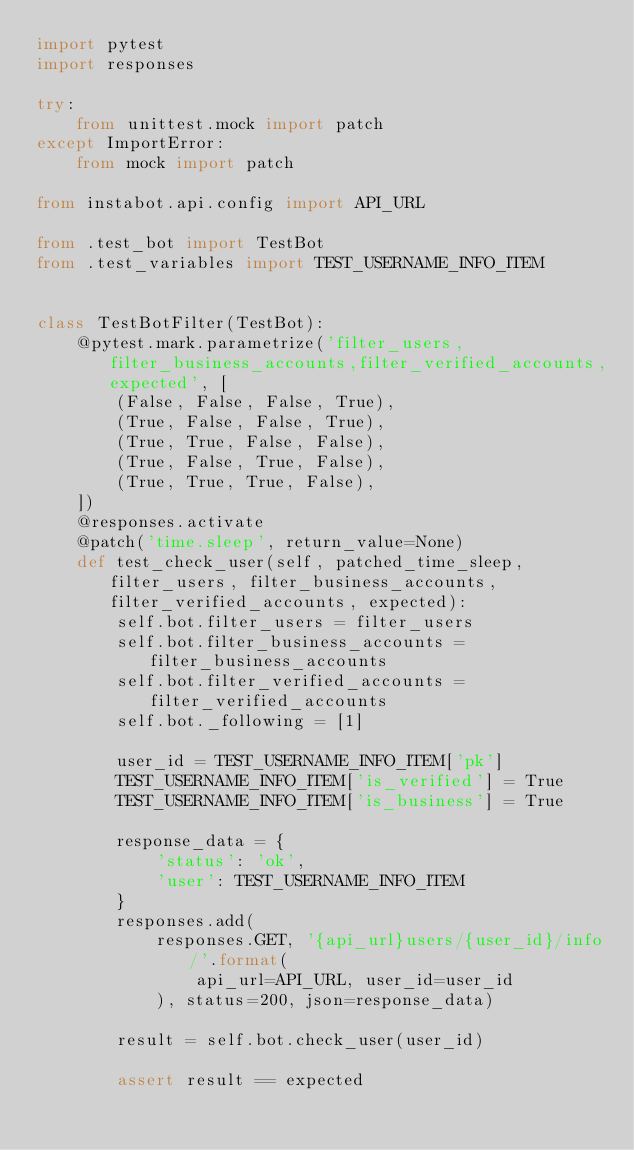Convert code to text. <code><loc_0><loc_0><loc_500><loc_500><_Python_>import pytest
import responses

try:
    from unittest.mock import patch
except ImportError:
    from mock import patch

from instabot.api.config import API_URL

from .test_bot import TestBot
from .test_variables import TEST_USERNAME_INFO_ITEM


class TestBotFilter(TestBot):
    @pytest.mark.parametrize('filter_users,filter_business_accounts,filter_verified_accounts,expected', [
        (False, False, False, True),
        (True, False, False, True),
        (True, True, False, False),
        (True, False, True, False),
        (True, True, True, False),
    ])
    @responses.activate
    @patch('time.sleep', return_value=None)
    def test_check_user(self, patched_time_sleep, filter_users, filter_business_accounts, filter_verified_accounts, expected):
        self.bot.filter_users = filter_users
        self.bot.filter_business_accounts = filter_business_accounts
        self.bot.filter_verified_accounts = filter_verified_accounts
        self.bot._following = [1]

        user_id = TEST_USERNAME_INFO_ITEM['pk']
        TEST_USERNAME_INFO_ITEM['is_verified'] = True
        TEST_USERNAME_INFO_ITEM['is_business'] = True

        response_data = {
            'status': 'ok',
            'user': TEST_USERNAME_INFO_ITEM
        }
        responses.add(
            responses.GET, '{api_url}users/{user_id}/info/'.format(
                api_url=API_URL, user_id=user_id
            ), status=200, json=response_data)

        result = self.bot.check_user(user_id)

        assert result == expected
</code> 